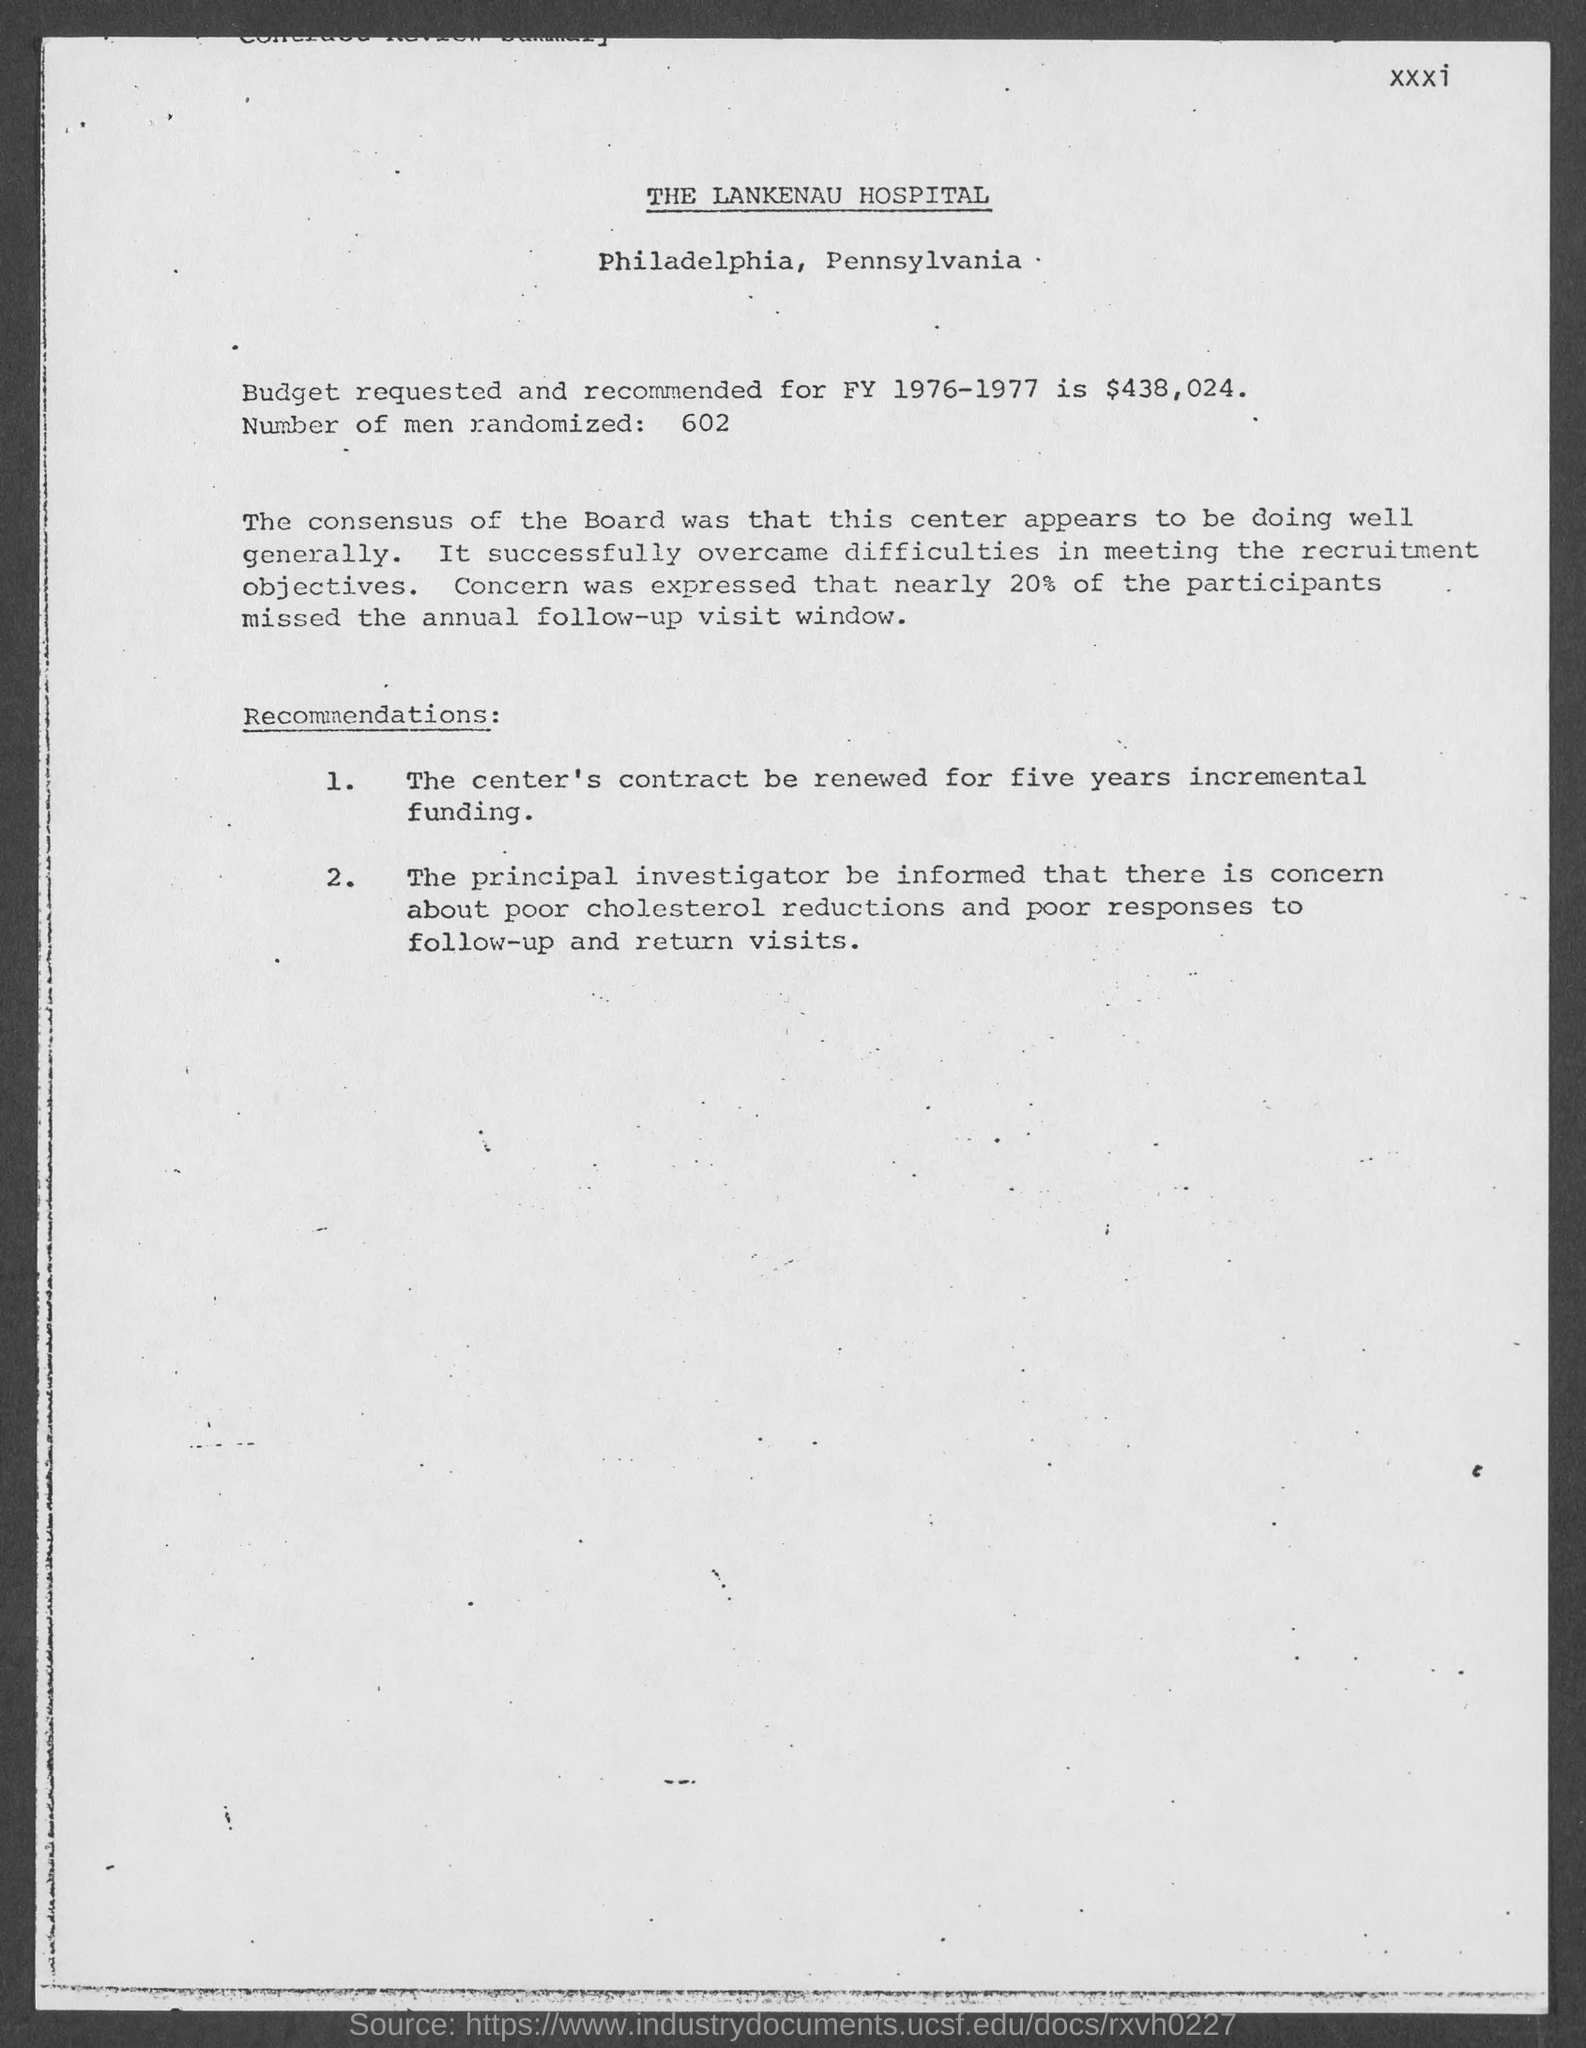Specify some key components in this picture. The budget requested and recommended for FY 1976-1977 is $438,024. Out of the 602 participants randomly selected, how many are men? The Lankenau Hospital is located in the county of Philadelphia. 